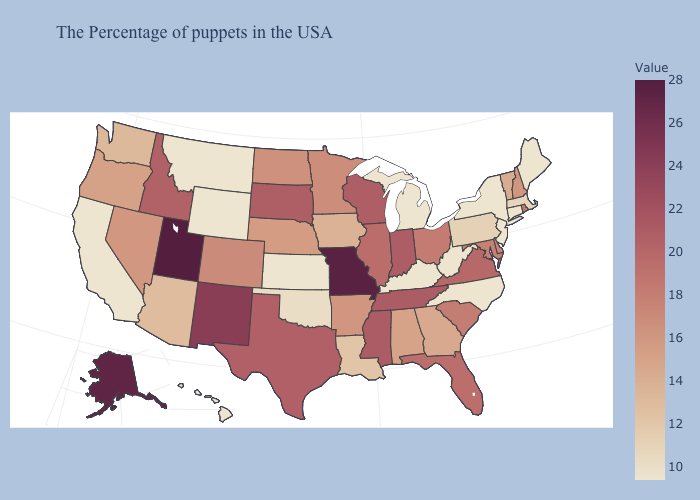Does Nebraska have the highest value in the USA?
Short answer required. No. Does Idaho have the highest value in the USA?
Keep it brief. No. Among the states that border Illinois , does Indiana have the highest value?
Answer briefly. No. Among the states that border Rhode Island , which have the lowest value?
Answer briefly. Connecticut. Among the states that border Maryland , does West Virginia have the lowest value?
Quick response, please. Yes. Which states hav the highest value in the South?
Short answer required. Tennessee, Mississippi. 